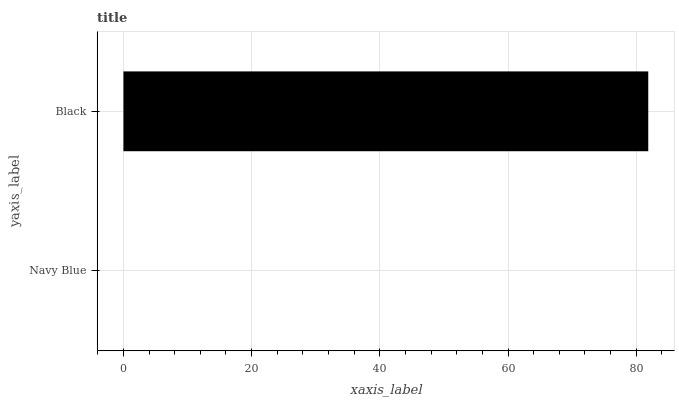Is Navy Blue the minimum?
Answer yes or no. Yes. Is Black the maximum?
Answer yes or no. Yes. Is Black the minimum?
Answer yes or no. No. Is Black greater than Navy Blue?
Answer yes or no. Yes. Is Navy Blue less than Black?
Answer yes or no. Yes. Is Navy Blue greater than Black?
Answer yes or no. No. Is Black less than Navy Blue?
Answer yes or no. No. Is Black the high median?
Answer yes or no. Yes. Is Navy Blue the low median?
Answer yes or no. Yes. Is Navy Blue the high median?
Answer yes or no. No. Is Black the low median?
Answer yes or no. No. 